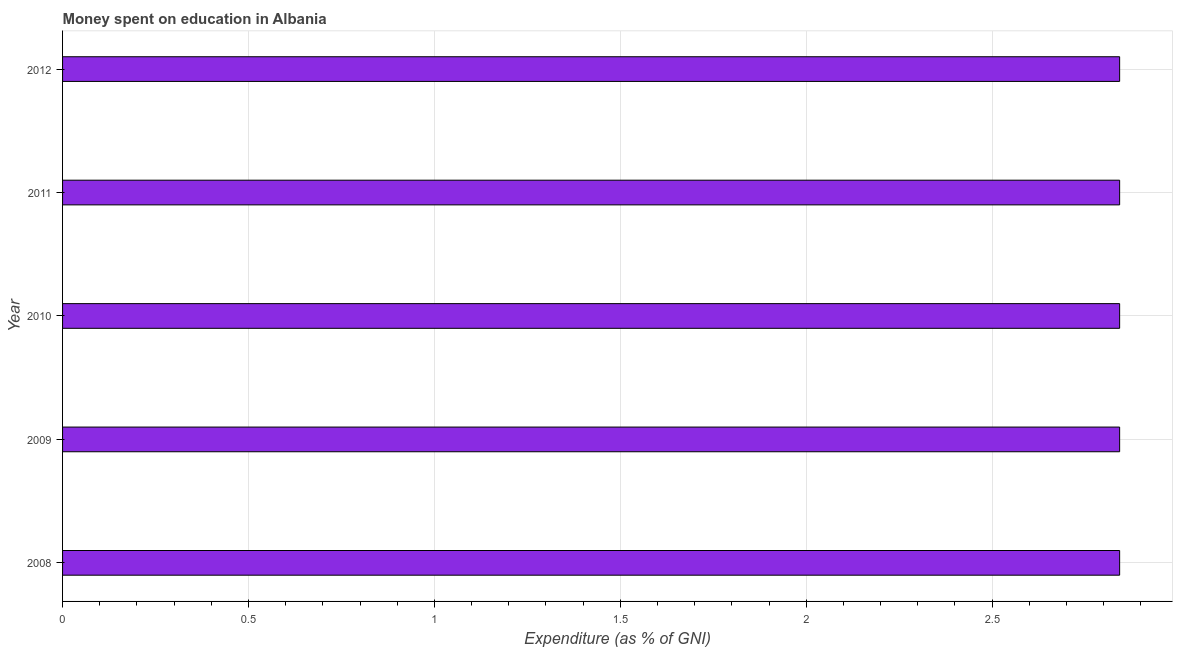Does the graph contain any zero values?
Provide a short and direct response. No. Does the graph contain grids?
Make the answer very short. Yes. What is the title of the graph?
Make the answer very short. Money spent on education in Albania. What is the label or title of the X-axis?
Provide a short and direct response. Expenditure (as % of GNI). What is the expenditure on education in 2010?
Your answer should be very brief. 2.84. Across all years, what is the maximum expenditure on education?
Your response must be concise. 2.84. Across all years, what is the minimum expenditure on education?
Give a very brief answer. 2.84. In which year was the expenditure on education maximum?
Provide a short and direct response. 2008. In which year was the expenditure on education minimum?
Your answer should be very brief. 2008. What is the sum of the expenditure on education?
Give a very brief answer. 14.21. What is the difference between the expenditure on education in 2011 and 2012?
Offer a terse response. 0. What is the average expenditure on education per year?
Your answer should be compact. 2.84. What is the median expenditure on education?
Make the answer very short. 2.84. What is the ratio of the expenditure on education in 2008 to that in 2011?
Your response must be concise. 1. What is the difference between the highest and the second highest expenditure on education?
Offer a terse response. 0. Is the sum of the expenditure on education in 2008 and 2009 greater than the maximum expenditure on education across all years?
Keep it short and to the point. Yes. Are all the bars in the graph horizontal?
Provide a short and direct response. Yes. What is the difference between two consecutive major ticks on the X-axis?
Your response must be concise. 0.5. Are the values on the major ticks of X-axis written in scientific E-notation?
Provide a succinct answer. No. What is the Expenditure (as % of GNI) of 2008?
Provide a succinct answer. 2.84. What is the Expenditure (as % of GNI) of 2009?
Offer a terse response. 2.84. What is the Expenditure (as % of GNI) in 2010?
Ensure brevity in your answer.  2.84. What is the Expenditure (as % of GNI) in 2011?
Keep it short and to the point. 2.84. What is the Expenditure (as % of GNI) in 2012?
Your answer should be very brief. 2.84. What is the difference between the Expenditure (as % of GNI) in 2008 and 2009?
Your answer should be very brief. 0. What is the difference between the Expenditure (as % of GNI) in 2008 and 2011?
Keep it short and to the point. 0. What is the difference between the Expenditure (as % of GNI) in 2009 and 2010?
Ensure brevity in your answer.  0. What is the difference between the Expenditure (as % of GNI) in 2009 and 2012?
Your response must be concise. 0. What is the difference between the Expenditure (as % of GNI) in 2010 and 2012?
Offer a terse response. 0. What is the ratio of the Expenditure (as % of GNI) in 2008 to that in 2010?
Make the answer very short. 1. What is the ratio of the Expenditure (as % of GNI) in 2008 to that in 2012?
Ensure brevity in your answer.  1. What is the ratio of the Expenditure (as % of GNI) in 2010 to that in 2012?
Keep it short and to the point. 1. 